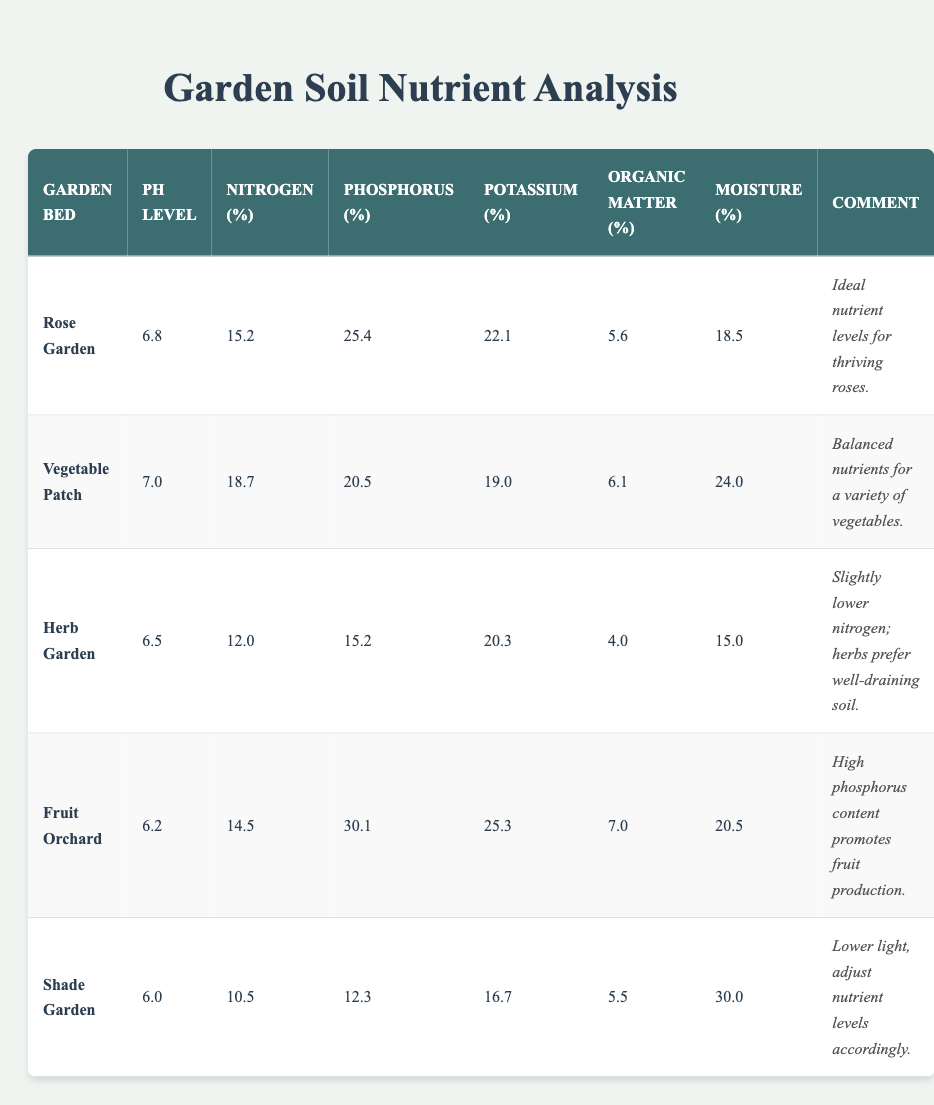What is the pH level of the Shade Garden? The pH level for the Shade Garden is clearly stated in the table under the relevant column. It can be found in the row designated for the Shade Garden.
Answer: 6.0 Which garden bed has the highest nitrogen content? Looking across the nitrogen content column for all garden beds, the Vegetable Patch shows the highest value of 18.7.
Answer: Vegetable Patch What is the average phosphorus content among all garden beds? To find the average, sum the phosphorus contents: (25.4 + 20.5 + 15.2 + 30.1 + 12.3) = 103.5. Then, divide by the number of gardens, which is 5: 103.5 / 5 = 20.7.
Answer: 20.7 Is it true that the Fruit Orchard has the highest potassium content? The potassium content for the Fruit Orchard is 25.3, which would be compared to all other garden beds. The highest value is actually for the Fruit Orchard, making the statement true.
Answer: Yes What is the difference in organic matter content between the Rose Garden and the Herb Garden? The organic matter for the Rose Garden is 5.6 and for the Herb Garden is 4.0. The difference is calculated as 5.6 - 4.0 = 1.6.
Answer: 1.6 Which garden bed has the lowest moisture content, and what is that value? Looking at the moisture content values, the Herb Garden shows a value of 15.0, which is the lowest compared to others.
Answer: Herb Garden; 15.0 What is the moisture content of the Vegetable Patch? Reference the table under the moisture content column for the Vegetable Patch row. The corresponding value is listed clearly.
Answer: 24.0 Do all garden beds have an organic matter content greater than 4%? Checking the organic matter values, the Herb Garden has a content of 4.0%, which is not greater than 4%, making the statement false.
Answer: No 